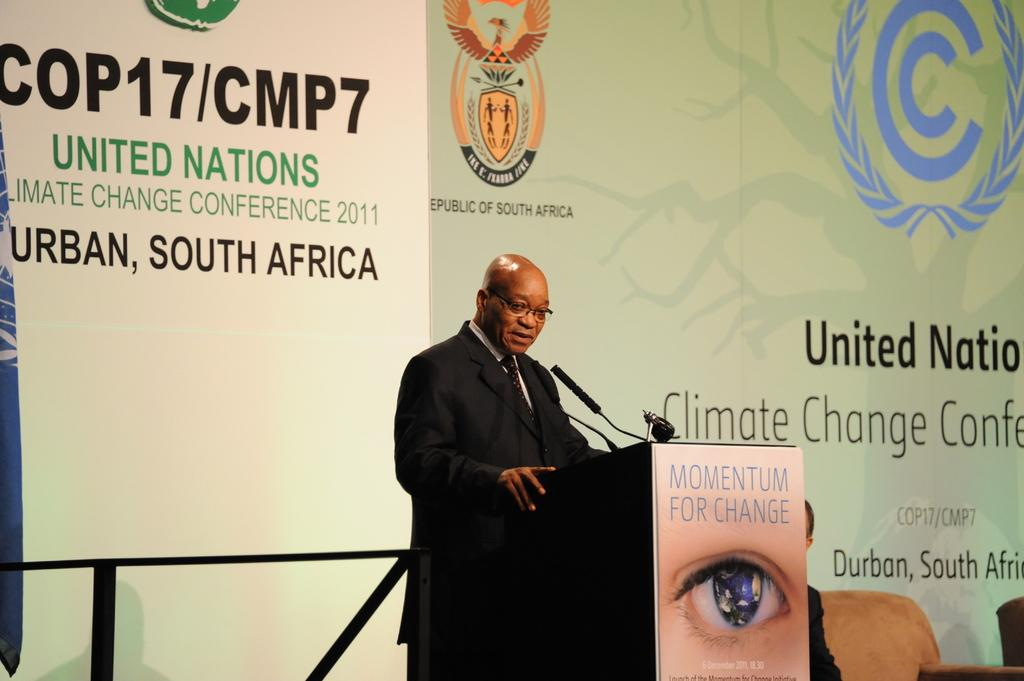What is the person in the image doing? The person is standing near a podium. What object is present for the person to use for speaking? There is a microphone in the image. What can be seen in the background of the image? There is a board with text and logos in the background. What type of toys can be seen on the podium in the image? There are no toys present on the podium or in the image. Is the person's parent visible in the image? There is no information about the person's parent in the image or the provided facts. 